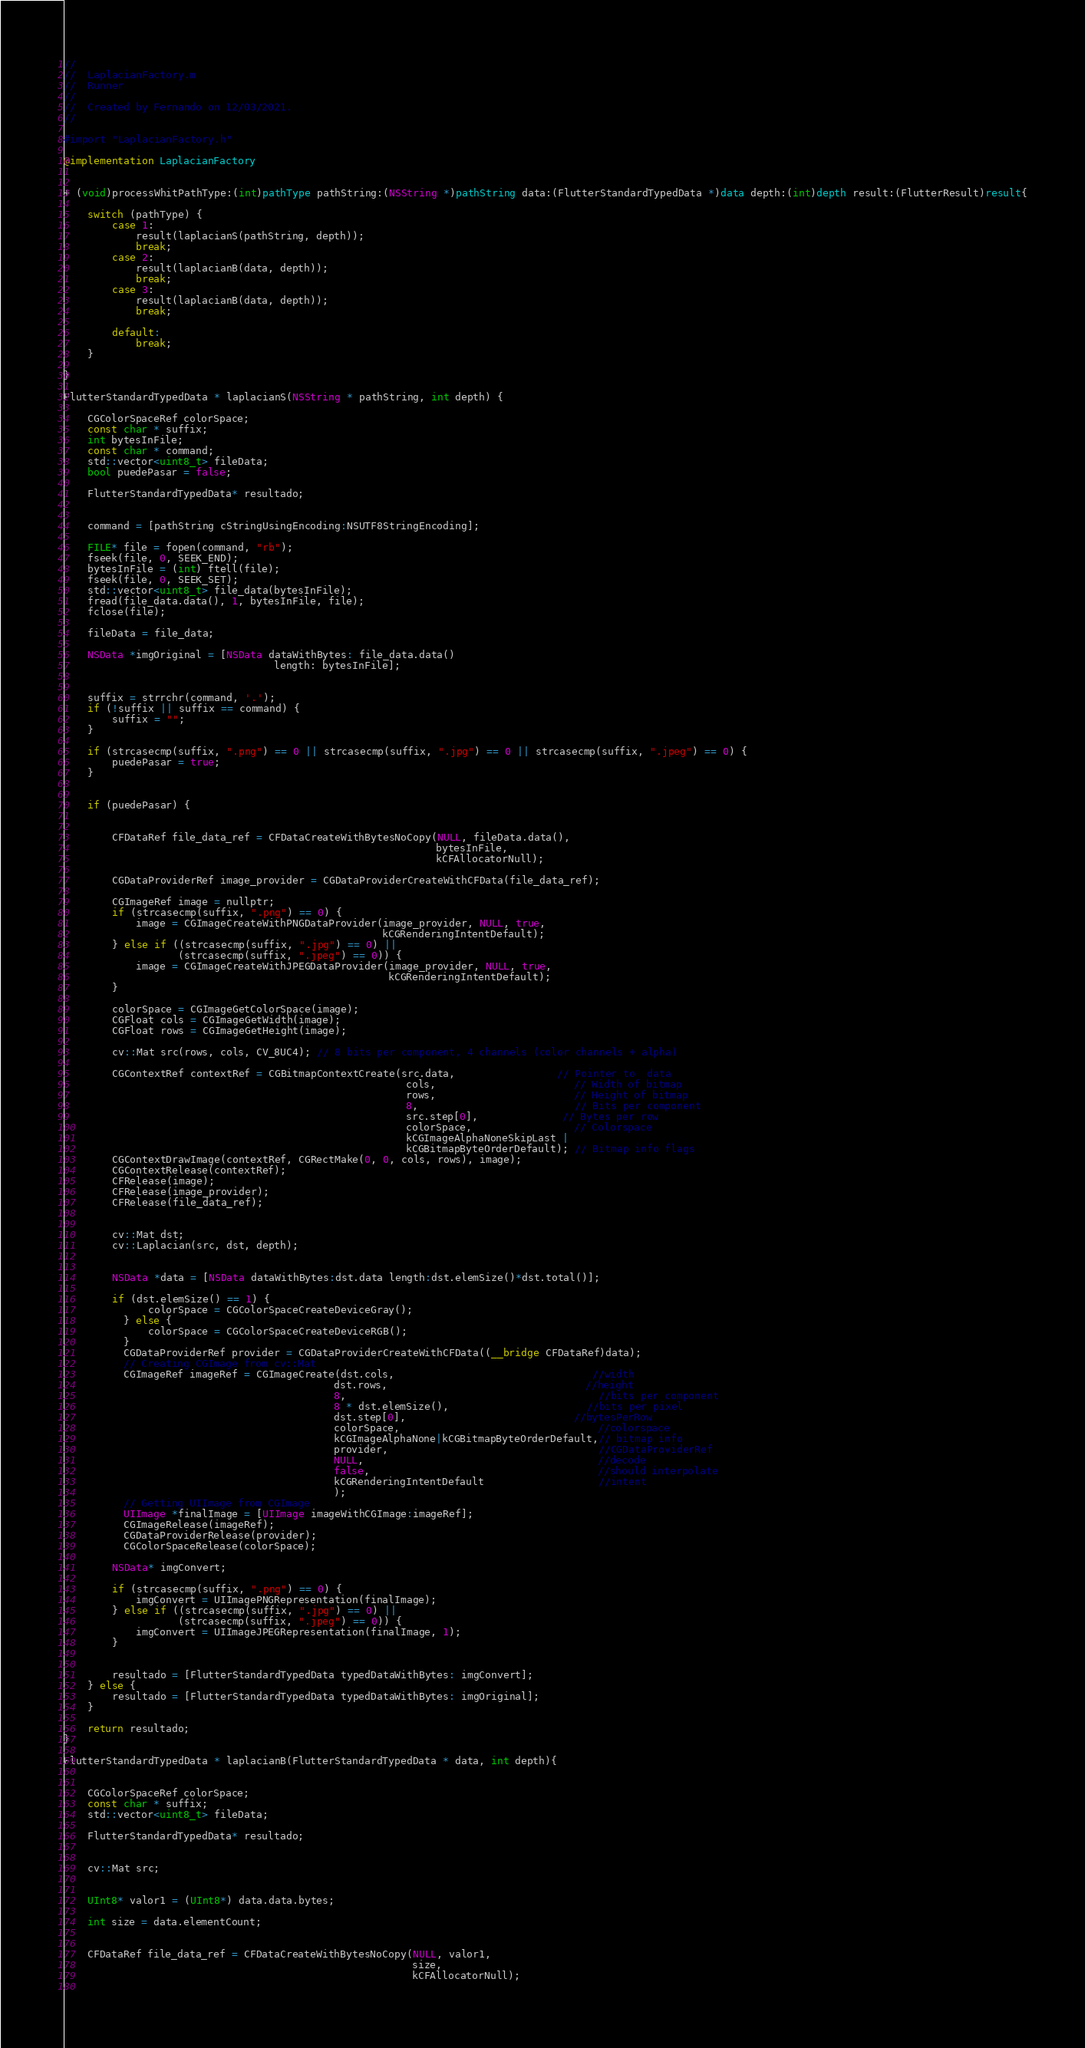Convert code to text. <code><loc_0><loc_0><loc_500><loc_500><_ObjectiveC_>//
//  LaplacianFactory.m
//  Runner
//
//  Created by Fernando on 12/03/2021.
//

#import "LaplacianFactory.h"

@implementation LaplacianFactory


+ (void)processWhitPathType:(int)pathType pathString:(NSString *)pathString data:(FlutterStandardTypedData *)data depth:(int)depth result:(FlutterResult)result{
    
    switch (pathType) {
        case 1:
            result(laplacianS(pathString, depth));
            break;
        case 2:
            result(laplacianB(data, depth));
            break;
        case 3:
            result(laplacianB(data, depth));
            break;
        
        default:
            break;
    }
    
}

FlutterStandardTypedData * laplacianS(NSString * pathString, int depth) {
    
    CGColorSpaceRef colorSpace;
    const char * suffix;
    int bytesInFile;
    const char * command;
    std::vector<uint8_t> fileData;
    bool puedePasar = false;
    
    FlutterStandardTypedData* resultado;
    
    
    command = [pathString cStringUsingEncoding:NSUTF8StringEncoding];
    
    FILE* file = fopen(command, "rb");
    fseek(file, 0, SEEK_END);
    bytesInFile = (int) ftell(file);
    fseek(file, 0, SEEK_SET);
    std::vector<uint8_t> file_data(bytesInFile);
    fread(file_data.data(), 1, bytesInFile, file);
    fclose(file);
    
    fileData = file_data;
    
    NSData *imgOriginal = [NSData dataWithBytes: file_data.data()
                                   length: bytesInFile];
    
    
    suffix = strrchr(command, '.');
    if (!suffix || suffix == command) {
        suffix = "";
    }
    
    if (strcasecmp(suffix, ".png") == 0 || strcasecmp(suffix, ".jpg") == 0 || strcasecmp(suffix, ".jpeg") == 0) {
        puedePasar = true;
    }
    

    if (puedePasar) {
        
        
        CFDataRef file_data_ref = CFDataCreateWithBytesNoCopy(NULL, fileData.data(),
                                                              bytesInFile,
                                                              kCFAllocatorNull);
        
        CGDataProviderRef image_provider = CGDataProviderCreateWithCFData(file_data_ref);
        
        CGImageRef image = nullptr;
        if (strcasecmp(suffix, ".png") == 0) {
            image = CGImageCreateWithPNGDataProvider(image_provider, NULL, true,
                                                     kCGRenderingIntentDefault);
        } else if ((strcasecmp(suffix, ".jpg") == 0) ||
                   (strcasecmp(suffix, ".jpeg") == 0)) {
            image = CGImageCreateWithJPEGDataProvider(image_provider, NULL, true,
                                                      kCGRenderingIntentDefault);
        }
        
        colorSpace = CGImageGetColorSpace(image);
        CGFloat cols = CGImageGetWidth(image);
        CGFloat rows = CGImageGetHeight(image);
        
        cv::Mat src(rows, cols, CV_8UC4); // 8 bits per component, 4 channels (color channels + alpha)
        
        CGContextRef contextRef = CGBitmapContextCreate(src.data,                 // Pointer to  data
                                                         cols,                       // Width of bitmap
                                                         rows,                       // Height of bitmap
                                                         8,                          // Bits per component
                                                         src.step[0],              // Bytes per row
                                                         colorSpace,                 // Colorspace
                                                         kCGImageAlphaNoneSkipLast |
                                                         kCGBitmapByteOrderDefault); // Bitmap info flags
        CGContextDrawImage(contextRef, CGRectMake(0, 0, cols, rows), image);
        CGContextRelease(contextRef);
        CFRelease(image);
        CFRelease(image_provider);
        CFRelease(file_data_ref);
        
        
        cv::Mat dst;
        cv::Laplacian(src, dst, depth);
        
        
        NSData *data = [NSData dataWithBytes:dst.data length:dst.elemSize()*dst.total()];
        
        if (dst.elemSize() == 1) {
              colorSpace = CGColorSpaceCreateDeviceGray();
          } else {
              colorSpace = CGColorSpaceCreateDeviceRGB();
          }
          CGDataProviderRef provider = CGDataProviderCreateWithCFData((__bridge CFDataRef)data);
          // Creating CGImage from cv::Mat
          CGImageRef imageRef = CGImageCreate(dst.cols,                                 //width
                                             dst.rows,                                 //height
                                             8,                                          //bits per component
                                             8 * dst.elemSize(),                       //bits per pixel
                                             dst.step[0],                            //bytesPerRow
                                             colorSpace,                                 //colorspace
                                             kCGImageAlphaNone|kCGBitmapByteOrderDefault,// bitmap info
                                             provider,                                   //CGDataProviderRef
                                             NULL,                                       //decode
                                             false,                                      //should interpolate
                                             kCGRenderingIntentDefault                   //intent
                                             );
          // Getting UIImage from CGImage
          UIImage *finalImage = [UIImage imageWithCGImage:imageRef];
          CGImageRelease(imageRef);
          CGDataProviderRelease(provider);
          CGColorSpaceRelease(colorSpace);
        
        NSData* imgConvert;
        
        if (strcasecmp(suffix, ".png") == 0) {
            imgConvert = UIImagePNGRepresentation(finalImage);
        } else if ((strcasecmp(suffix, ".jpg") == 0) ||
                   (strcasecmp(suffix, ".jpeg") == 0)) {
            imgConvert = UIImageJPEGRepresentation(finalImage, 1);
        }
        
        
        resultado = [FlutterStandardTypedData typedDataWithBytes: imgConvert];
    } else {
        resultado = [FlutterStandardTypedData typedDataWithBytes: imgOriginal];
    }
    
    return resultado;
}

FlutterStandardTypedData * laplacianB(FlutterStandardTypedData * data, int depth){
    

    CGColorSpaceRef colorSpace;
    const char * suffix;
    std::vector<uint8_t> fileData;
    
    FlutterStandardTypedData* resultado;
    
    
    cv::Mat src;
    
    
    UInt8* valor1 = (UInt8*) data.data.bytes;
    
    int size = data.elementCount;
    

    CFDataRef file_data_ref = CFDataCreateWithBytesNoCopy(NULL, valor1,
                                                          size,
                                                          kCFAllocatorNull);
    </code> 